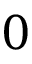<formula> <loc_0><loc_0><loc_500><loc_500>0</formula> 